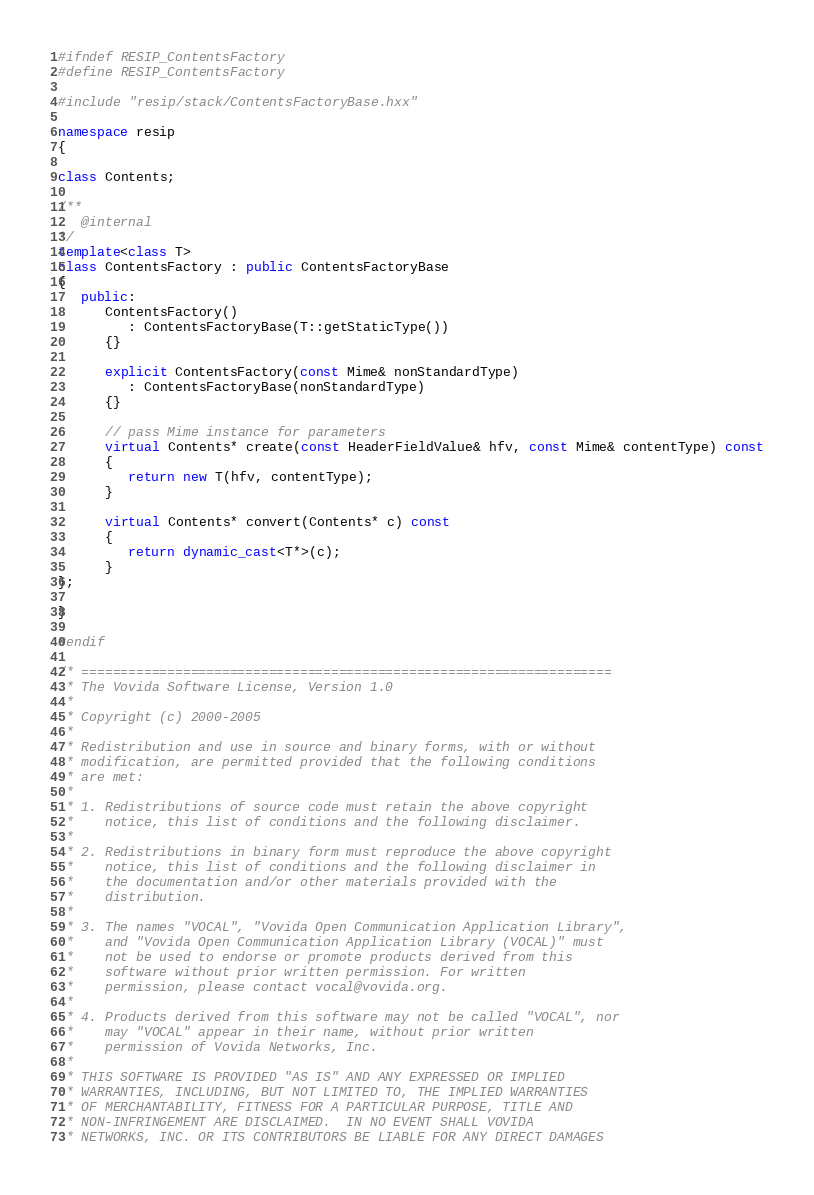Convert code to text. <code><loc_0><loc_0><loc_500><loc_500><_C++_>#ifndef RESIP_ContentsFactory
#define RESIP_ContentsFactory

#include "resip/stack/ContentsFactoryBase.hxx"

namespace resip
{

class Contents;

/**
   @internal
*/
template<class T>
class ContentsFactory : public ContentsFactoryBase
{
   public:
      ContentsFactory()
         : ContentsFactoryBase(T::getStaticType())
      {}

      explicit ContentsFactory(const Mime& nonStandardType)
         : ContentsFactoryBase(nonStandardType)
      {}

      // pass Mime instance for parameters
      virtual Contents* create(const HeaderFieldValue& hfv, const Mime& contentType) const
      {
         return new T(hfv, contentType);
      }

      virtual Contents* convert(Contents* c) const
      {
         return dynamic_cast<T*>(c);
      }
};

}

#endif

/* ====================================================================
 * The Vovida Software License, Version 1.0 
 * 
 * Copyright (c) 2000-2005
 * 
 * Redistribution and use in source and binary forms, with or without
 * modification, are permitted provided that the following conditions
 * are met:
 * 
 * 1. Redistributions of source code must retain the above copyright
 *    notice, this list of conditions and the following disclaimer.
 * 
 * 2. Redistributions in binary form must reproduce the above copyright
 *    notice, this list of conditions and the following disclaimer in
 *    the documentation and/or other materials provided with the
 *    distribution.
 * 
 * 3. The names "VOCAL", "Vovida Open Communication Application Library",
 *    and "Vovida Open Communication Application Library (VOCAL)" must
 *    not be used to endorse or promote products derived from this
 *    software without prior written permission. For written
 *    permission, please contact vocal@vovida.org.
 *
 * 4. Products derived from this software may not be called "VOCAL", nor
 *    may "VOCAL" appear in their name, without prior written
 *    permission of Vovida Networks, Inc.
 * 
 * THIS SOFTWARE IS PROVIDED "AS IS" AND ANY EXPRESSED OR IMPLIED
 * WARRANTIES, INCLUDING, BUT NOT LIMITED TO, THE IMPLIED WARRANTIES
 * OF MERCHANTABILITY, FITNESS FOR A PARTICULAR PURPOSE, TITLE AND
 * NON-INFRINGEMENT ARE DISCLAIMED.  IN NO EVENT SHALL VOVIDA
 * NETWORKS, INC. OR ITS CONTRIBUTORS BE LIABLE FOR ANY DIRECT DAMAGES</code> 